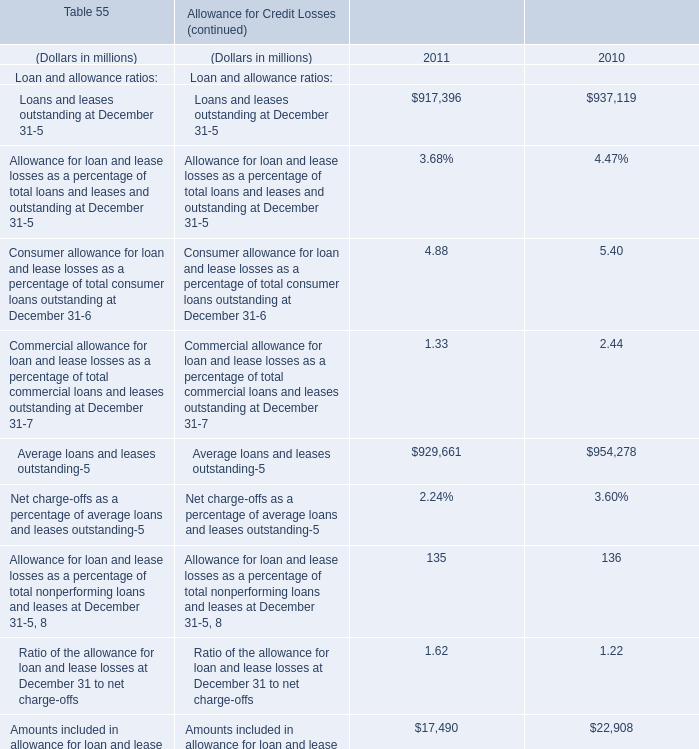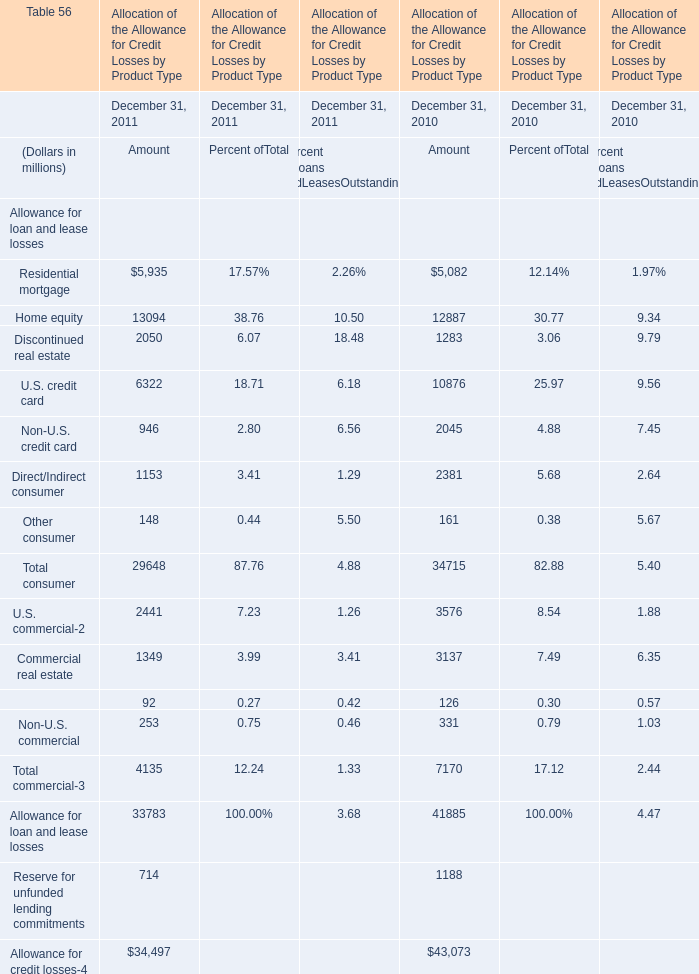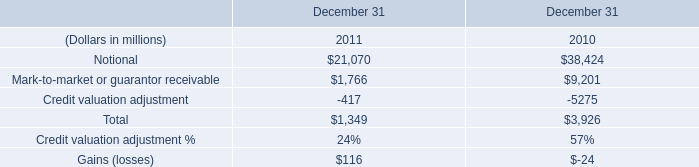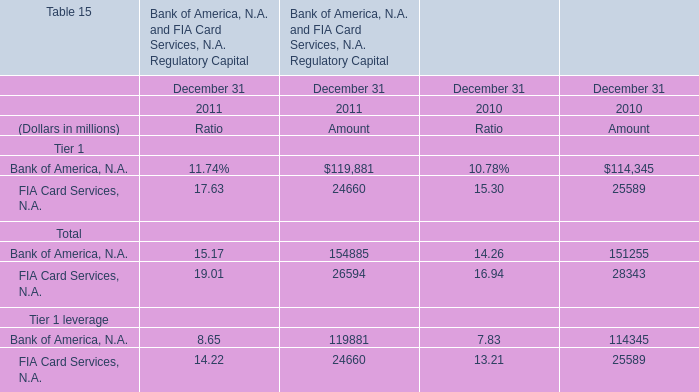What is the growing rate of Discontinued real estate in the years with the least Home equity ? 
Computations: ((2050 - 1283) / 1283)
Answer: 0.59782. 